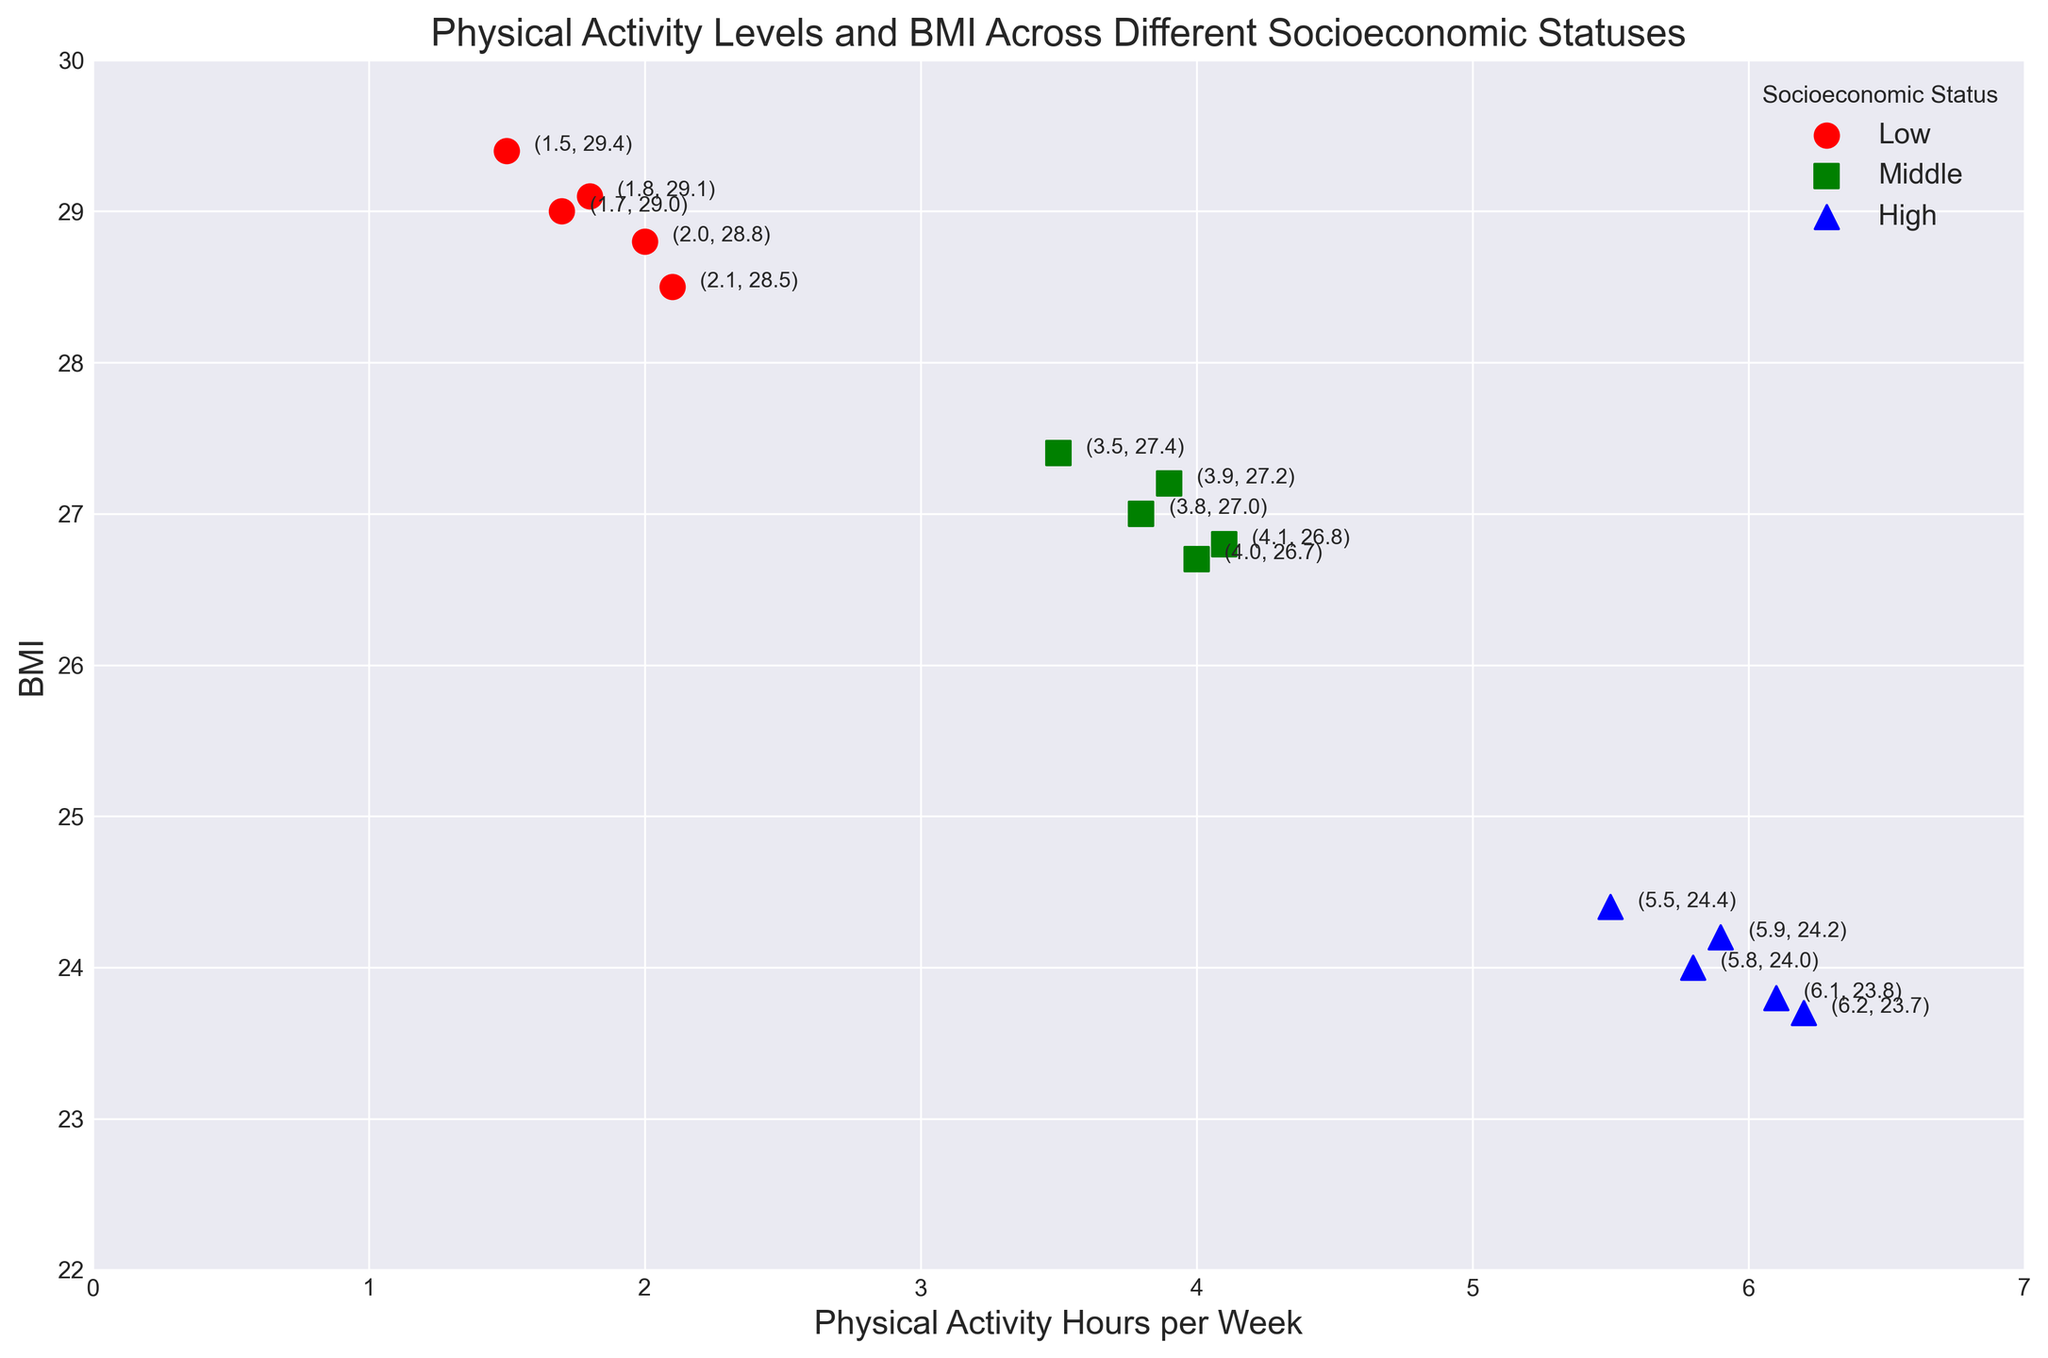What is the general trend of physical activity hours per week as socioeconomic status increases? Observing the scatter plot, as socioeconomic status increases from Low to High, the physical activity hours per week tend to increase.
Answer: Increasing How do the BMI values compare between the High and Low socioeconomic statuses? High socioeconomic status individuals have lower BMI values compared to Low socioeconomic status individuals, as seen in the blue markers being lower than the red ones on the BMI axis.
Answer: Lower What is the range of physical activity hours per week for the Middle socioeconomic status group? For the Middle socioeconomic status group, the physical activity hours range from the lowest value of 3.5 to the highest value of 4.1.
Answer: 3.5 to 4.1 What is the average BMI for the Low socioeconomic status group? The BMI values for the Low group are 29.4, 29.0, 28.8, 29.1, and 28.5. The sum of these values is 144.8. Dividing by 5 gives an average of 28.96.
Answer: 28.96 How do the physical activity hours per week for the Middle socioeconomic status compare to those of the High socioeconomic status? Comparing the scatter points, the physical activity hours for the Middle group range from 3.5 to 4.1, whereas for the High group, they range from 5.5 to 6.2. The High group consistently engages in more physical activity per week than the Middle group.
Answer: Higher Which socioeconomic status group has the most consistent BMI values? Examining the scatter points' spread on the BMI axis, the High socioeconomic status group has the closest cluster of BMI values, ranging from 23.7 to 24.4, indicating the most consistency.
Answer: High What is the relationship between physical activity hours and BMI for the three socioeconomic statuses? Across all statuses, there is a general pattern where higher physical activity hours per week are associated with lower BMI. This is evident as points move towards higher physical activity hours, their corresponding BMI tends to decrease.
Answer: Inverse Relationship Between the Low and Middle socioeconomic statuses, which has fewer hours of physical activity on average? For the Low group, the physical activity hours are 1.5, 1.7, 2.0, 1.8, and 2.1. The sum is 9.1, averaging to 1.82. For the Middle group, the hours are 3.5, 3.8, 4.1, 3.9, and 4.0. The sum is 19.3, averaging to 3.86. Hence, the Low group has fewer physical activity hours on average.
Answer: Low Which group shows the highest individual physical activity hour per week and what is the corresponding BMI? The highest individual physical activity hour per week is seen in the High socioeconomic status group with a value of 6.2, and the corresponding BMI for this data point is 23.7.
Answer: High, 23.7 What is the average physical activity hours per week for the High socioeconomic status group? The physical activity hours for the High group are 5.5, 5.8, 6.1, 5.9, and 6.2. The sum of these values is 29.5. Dividing by 5 gives an average of 5.9.
Answer: 5.9 